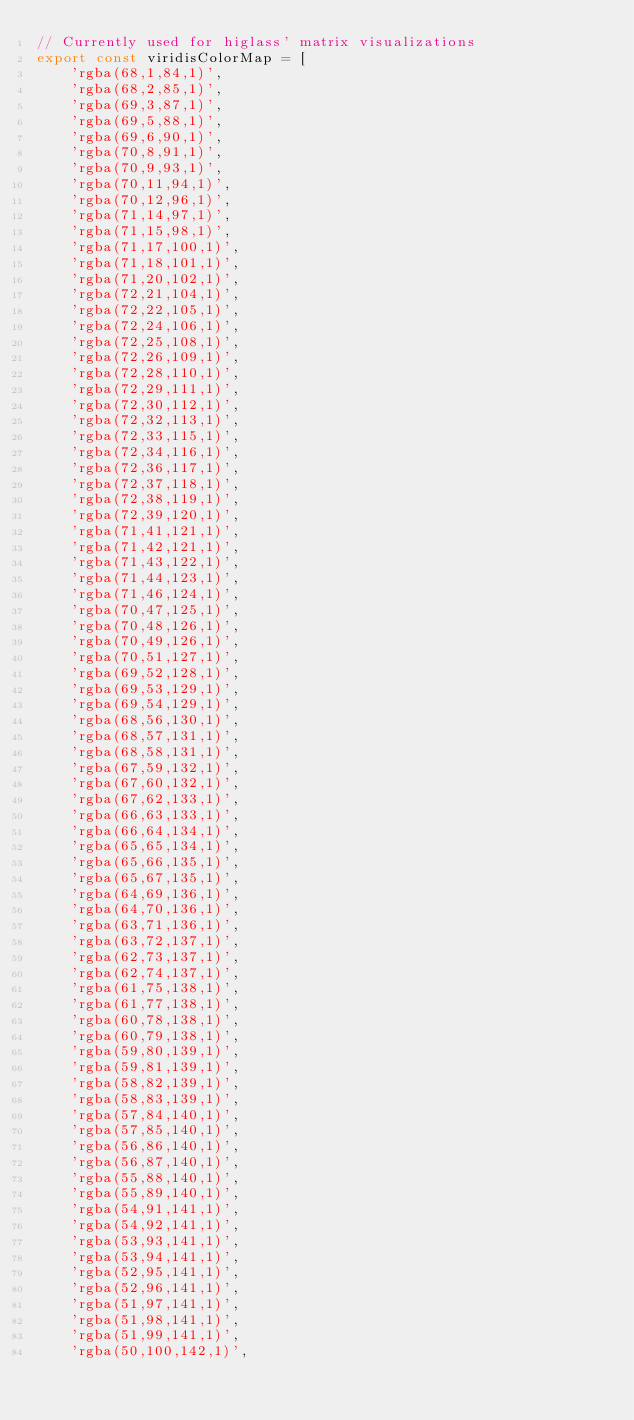Convert code to text. <code><loc_0><loc_0><loc_500><loc_500><_TypeScript_>// Currently used for higlass' matrix visualizations
export const viridisColorMap = [
    'rgba(68,1,84,1)',
    'rgba(68,2,85,1)',
    'rgba(69,3,87,1)',
    'rgba(69,5,88,1)',
    'rgba(69,6,90,1)',
    'rgba(70,8,91,1)',
    'rgba(70,9,93,1)',
    'rgba(70,11,94,1)',
    'rgba(70,12,96,1)',
    'rgba(71,14,97,1)',
    'rgba(71,15,98,1)',
    'rgba(71,17,100,1)',
    'rgba(71,18,101,1)',
    'rgba(71,20,102,1)',
    'rgba(72,21,104,1)',
    'rgba(72,22,105,1)',
    'rgba(72,24,106,1)',
    'rgba(72,25,108,1)',
    'rgba(72,26,109,1)',
    'rgba(72,28,110,1)',
    'rgba(72,29,111,1)',
    'rgba(72,30,112,1)',
    'rgba(72,32,113,1)',
    'rgba(72,33,115,1)',
    'rgba(72,34,116,1)',
    'rgba(72,36,117,1)',
    'rgba(72,37,118,1)',
    'rgba(72,38,119,1)',
    'rgba(72,39,120,1)',
    'rgba(71,41,121,1)',
    'rgba(71,42,121,1)',
    'rgba(71,43,122,1)',
    'rgba(71,44,123,1)',
    'rgba(71,46,124,1)',
    'rgba(70,47,125,1)',
    'rgba(70,48,126,1)',
    'rgba(70,49,126,1)',
    'rgba(70,51,127,1)',
    'rgba(69,52,128,1)',
    'rgba(69,53,129,1)',
    'rgba(69,54,129,1)',
    'rgba(68,56,130,1)',
    'rgba(68,57,131,1)',
    'rgba(68,58,131,1)',
    'rgba(67,59,132,1)',
    'rgba(67,60,132,1)',
    'rgba(67,62,133,1)',
    'rgba(66,63,133,1)',
    'rgba(66,64,134,1)',
    'rgba(65,65,134,1)',
    'rgba(65,66,135,1)',
    'rgba(65,67,135,1)',
    'rgba(64,69,136,1)',
    'rgba(64,70,136,1)',
    'rgba(63,71,136,1)',
    'rgba(63,72,137,1)',
    'rgba(62,73,137,1)',
    'rgba(62,74,137,1)',
    'rgba(61,75,138,1)',
    'rgba(61,77,138,1)',
    'rgba(60,78,138,1)',
    'rgba(60,79,138,1)',
    'rgba(59,80,139,1)',
    'rgba(59,81,139,1)',
    'rgba(58,82,139,1)',
    'rgba(58,83,139,1)',
    'rgba(57,84,140,1)',
    'rgba(57,85,140,1)',
    'rgba(56,86,140,1)',
    'rgba(56,87,140,1)',
    'rgba(55,88,140,1)',
    'rgba(55,89,140,1)',
    'rgba(54,91,141,1)',
    'rgba(54,92,141,1)',
    'rgba(53,93,141,1)',
    'rgba(53,94,141,1)',
    'rgba(52,95,141,1)',
    'rgba(52,96,141,1)',
    'rgba(51,97,141,1)',
    'rgba(51,98,141,1)',
    'rgba(51,99,141,1)',
    'rgba(50,100,142,1)',</code> 